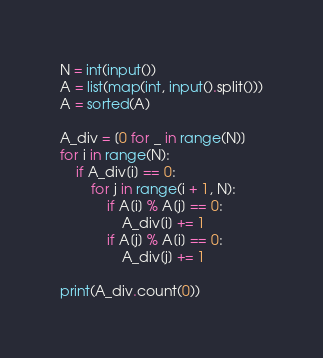Convert code to text. <code><loc_0><loc_0><loc_500><loc_500><_Python_>N = int(input())
A = list(map(int, input().split()))
A = sorted(A)

A_div = [0 for _ in range(N)]
for i in range(N):
    if A_div[i] == 0:
        for j in range(i + 1, N):
            if A[i] % A[j] == 0:
                A_div[i] += 1
            if A[j] % A[i] == 0:
                A_div[j] += 1

print(A_div.count(0))</code> 